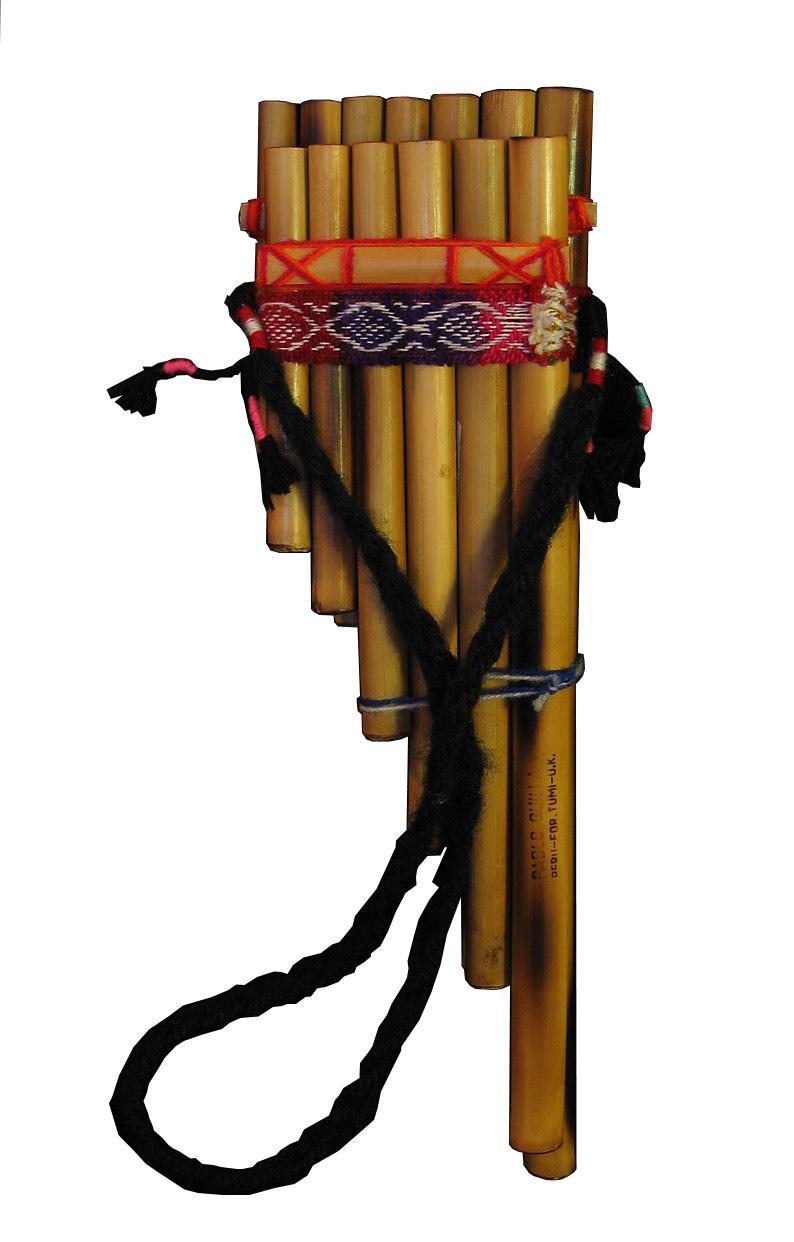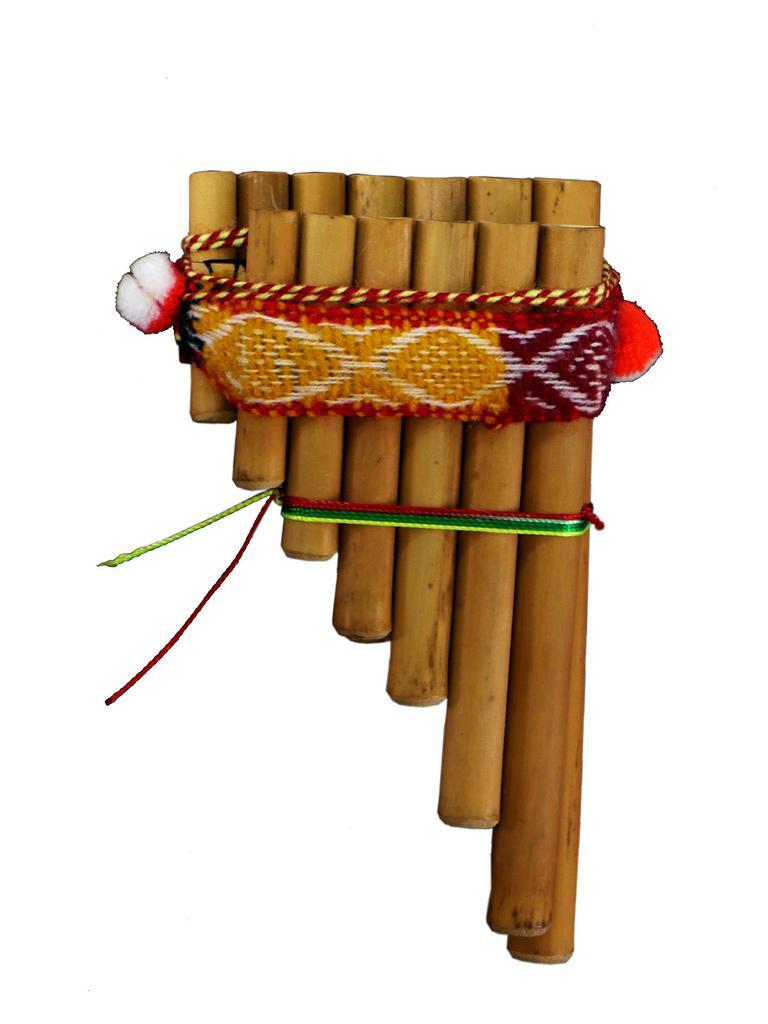The first image is the image on the left, the second image is the image on the right. Examine the images to the left and right. Is the description "The right image features an instrument with pom-pom balls on each side displayed vertically, with its wooden tube shapes arranged left-to-right from shortest to longest." accurate? Answer yes or no. Yes. The first image is the image on the left, the second image is the image on the right. For the images displayed, is the sentence "A carrying bag sits under the instrument in the image on the left." factually correct? Answer yes or no. No. 